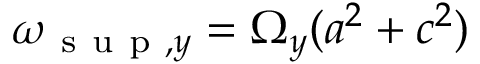<formula> <loc_0><loc_0><loc_500><loc_500>\omega _ { s u p , y } = \Omega _ { y } ( a ^ { 2 } + c ^ { 2 } )</formula> 